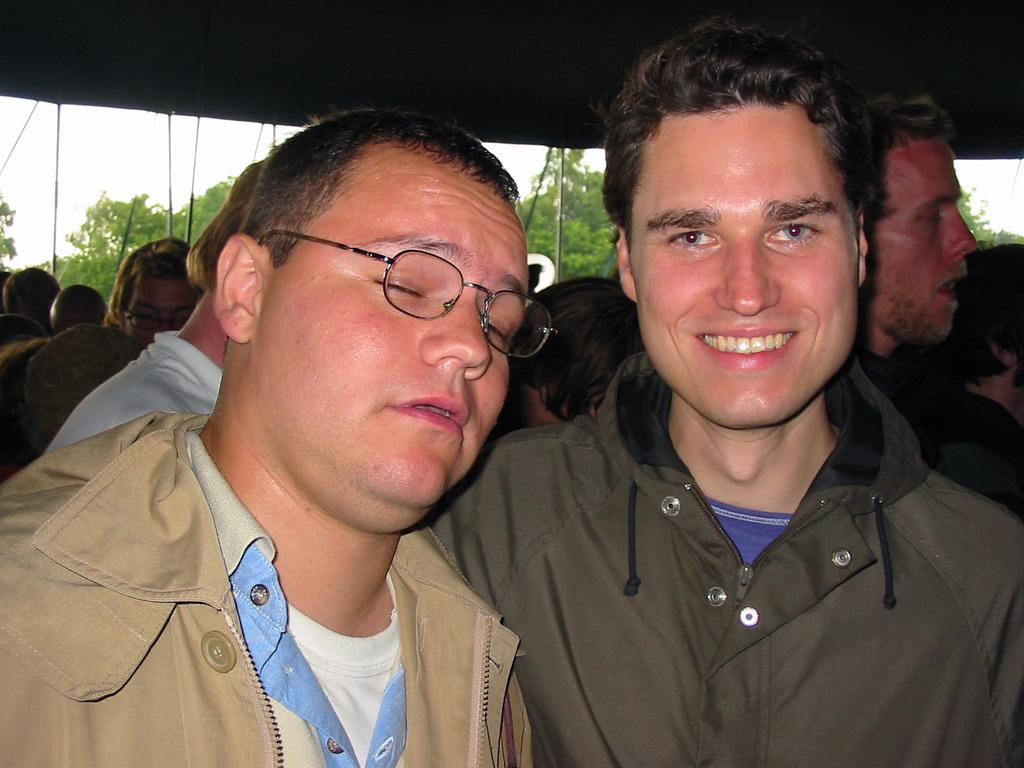What can be seen in the image? There are people, poles, trees, a roof, and the sky visible in the image. What are the poles used for? The purpose of the poles is not specified in the image, but they could be used for various purposes such as support or signage. What type of vegetation is present in the image? Trees are the type of vegetation present in the image. What part of a building can be seen in the image? A roof is visible in the image, which is a part of a building. What type of steel is used to make the stocking in the image? There is no stocking present in the image, and therefore no steel can be associated with it. 